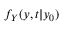Convert formula to latex. <formula><loc_0><loc_0><loc_500><loc_500>f _ { Y } ( y , t | y _ { 0 } )</formula> 